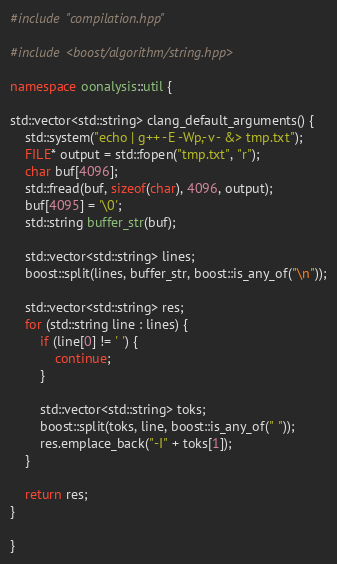Convert code to text. <code><loc_0><loc_0><loc_500><loc_500><_C++_>#include "compilation.hpp"

#include <boost/algorithm/string.hpp>

namespace oonalysis::util {

std::vector<std::string> clang_default_arguments() {
    std::system("echo | g++ -E -Wp,-v - &> tmp.txt");
    FILE* output = std::fopen("tmp.txt", "r");
    char buf[4096];
    std::fread(buf, sizeof(char), 4096, output);
    buf[4095] = '\0';
    std::string buffer_str(buf);

    std::vector<std::string> lines;
    boost::split(lines, buffer_str, boost::is_any_of("\n"));

    std::vector<std::string> res;
    for (std::string line : lines) {
        if (line[0] != ' ') {
            continue;
        }

        std::vector<std::string> toks;
        boost::split(toks, line, boost::is_any_of(" "));
        res.emplace_back("-I" + toks[1]);
    }

    return res;
}

}</code> 